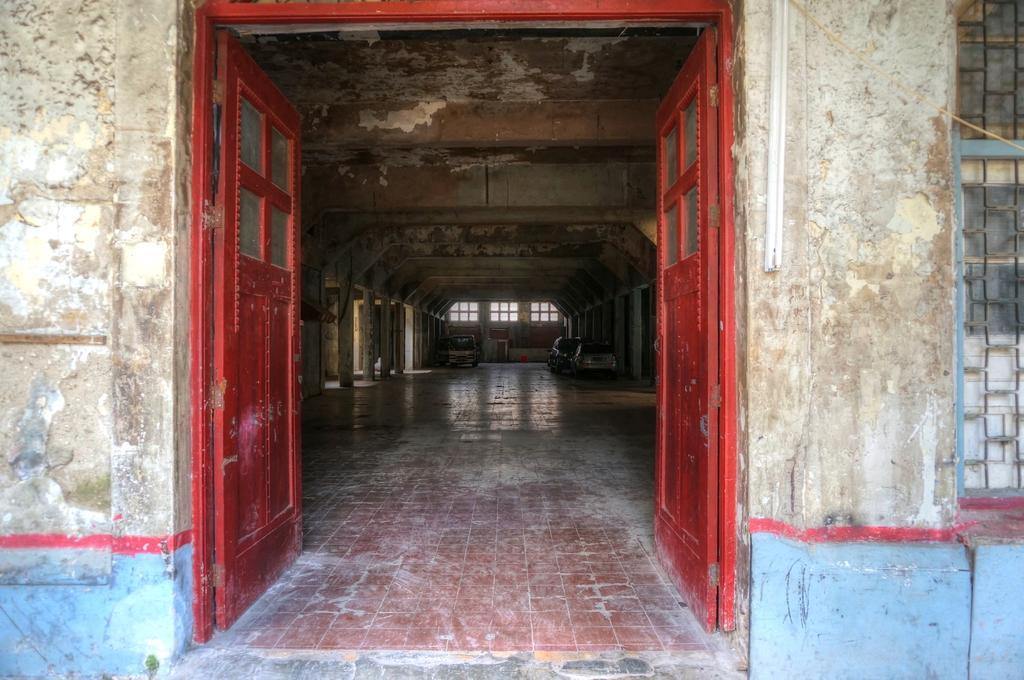Could you give a brief overview of what you see in this image? In the image there are red doors in the front, it is a entrance to a building, in the back there are window on the wall and there are pillars on either sides of the hall. 